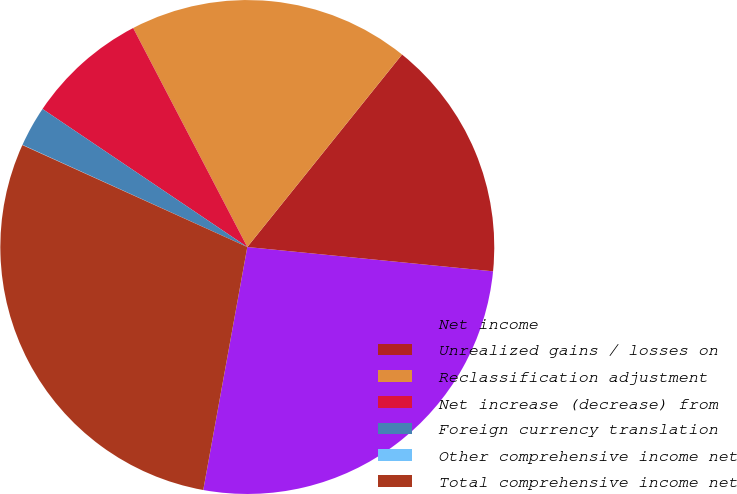Convert chart to OTSL. <chart><loc_0><loc_0><loc_500><loc_500><pie_chart><fcel>Net income<fcel>Unrealized gains / losses on<fcel>Reclassification adjustment<fcel>Net increase (decrease) from<fcel>Foreign currency translation<fcel>Other comprehensive income net<fcel>Total comprehensive income net<nl><fcel>26.28%<fcel>15.79%<fcel>18.42%<fcel>7.91%<fcel>2.65%<fcel>0.02%<fcel>28.91%<nl></chart> 